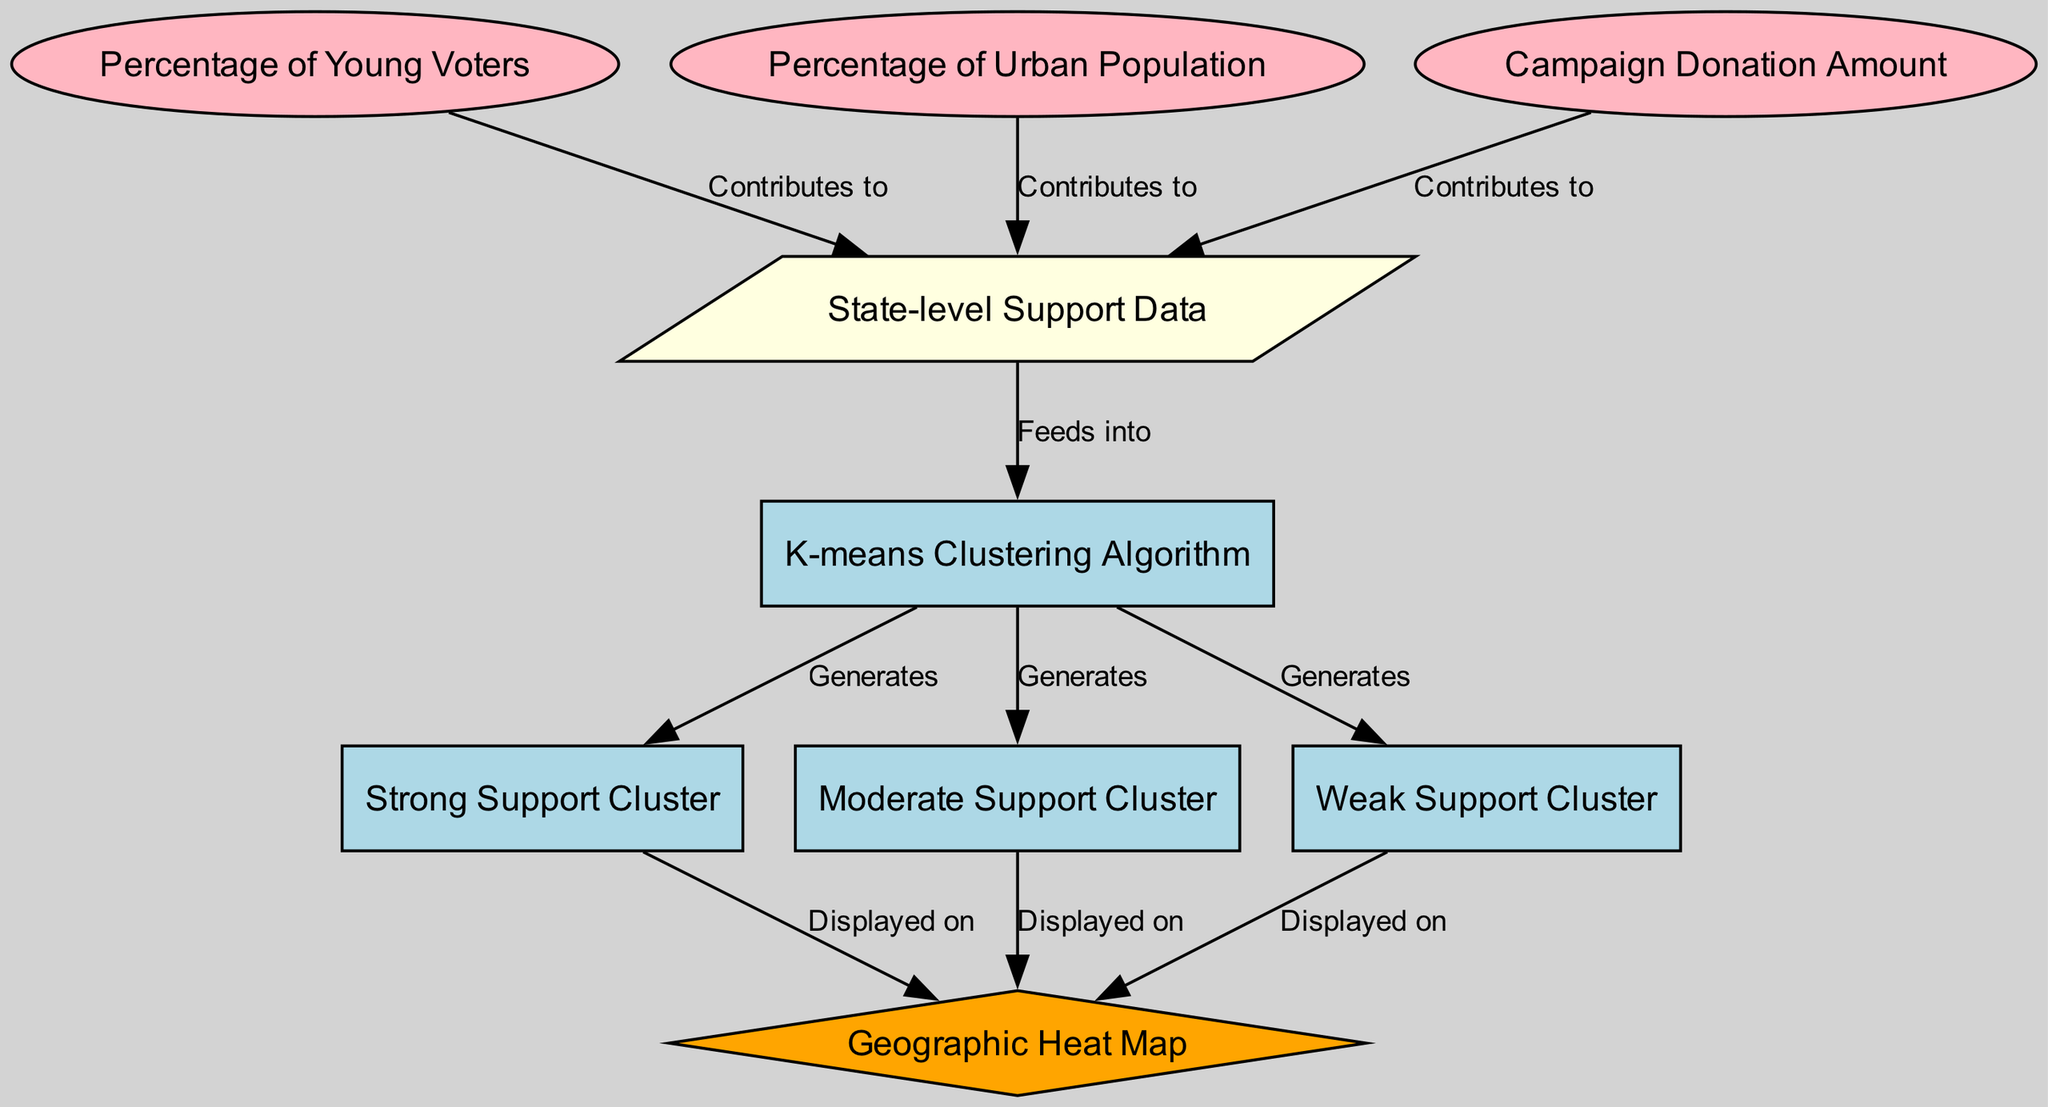What is the clustering algorithm used in this diagram? The diagram clearly labels the clustering algorithm as "K-means Clustering Algorithm." This can be found directly in the node labeled "cluster_algorithm."
Answer: K-means Clustering Algorithm How many features contribute to the state-level support data? The diagram shows three features that contribute to the "State-level Support Data": "Percentage of Young Voters," "Percentage of Urban Population," and "Campaign Donation Amount." Each feature is connected to the input data node.
Answer: Three What are the labels of the support clusters generated by the algorithm? The diagram specifies three support clusters generated by the K-means algorithm: "Strong Support Cluster," "Moderate Support Cluster," and "Weak Support Cluster." These labels are indicated in the nodes connected to the clustering algorithm.
Answer: Strong Support Cluster, Moderate Support Cluster, Weak Support Cluster Which cluster is displayed in orange color on the geographic heat map? In the diagram, the "visualization" node is highlighted in orange, indicating it represents the "Geographic Heat Map" that displays the clusters. Since the diagram doesn't specify color-coded clusters, it’s logical to conclude that all three clusters are integrated into the heat map.
Answer: Geographic Heat Map What contributes to the input data for the K-means clustering algorithm? According to the diagram, the features "Percentage of Young Voters," "Percentage of Urban Population," and "Campaign Donation Amount" all contribute to the "State-level Support Data" that feeds into the K-means Clustering Algorithm. These relationships are clearly illustrated with connecting edges.
Answer: Percentage of Young Voters, Percentage of Urban Population, Campaign Donation Amount Between which nodes does the edge labeled "Generates" exist? There are three edges labeled "Generates," connecting the clustering algorithm to all three clusters: "Strong Support Cluster," "Moderate Support Cluster," and "Weak Support Cluster." Each of these is a result of the K-means algorithm, indicating the output of the clustering process.
Answer: Strong Support Cluster, Moderate Support Cluster, Weak Support Cluster How many edges originate from the input data node? The input data node connects to three features and has three outgoing edges connecting it to the K-means clustering algorithm. This results in a total of three edges directly leading from "State-level Support Data" to the clustering algorithm, which defines the input data flow.
Answer: Three Which node represents the visualization of clusters on the map? The node labeled "visualization," which is visually represented with a diamond shape and colored orange, indicates where cluster data is displayed on the "Geographic Heat Map." The diagram specifies this node for mapping purposes.
Answer: Geographic Heat Map 